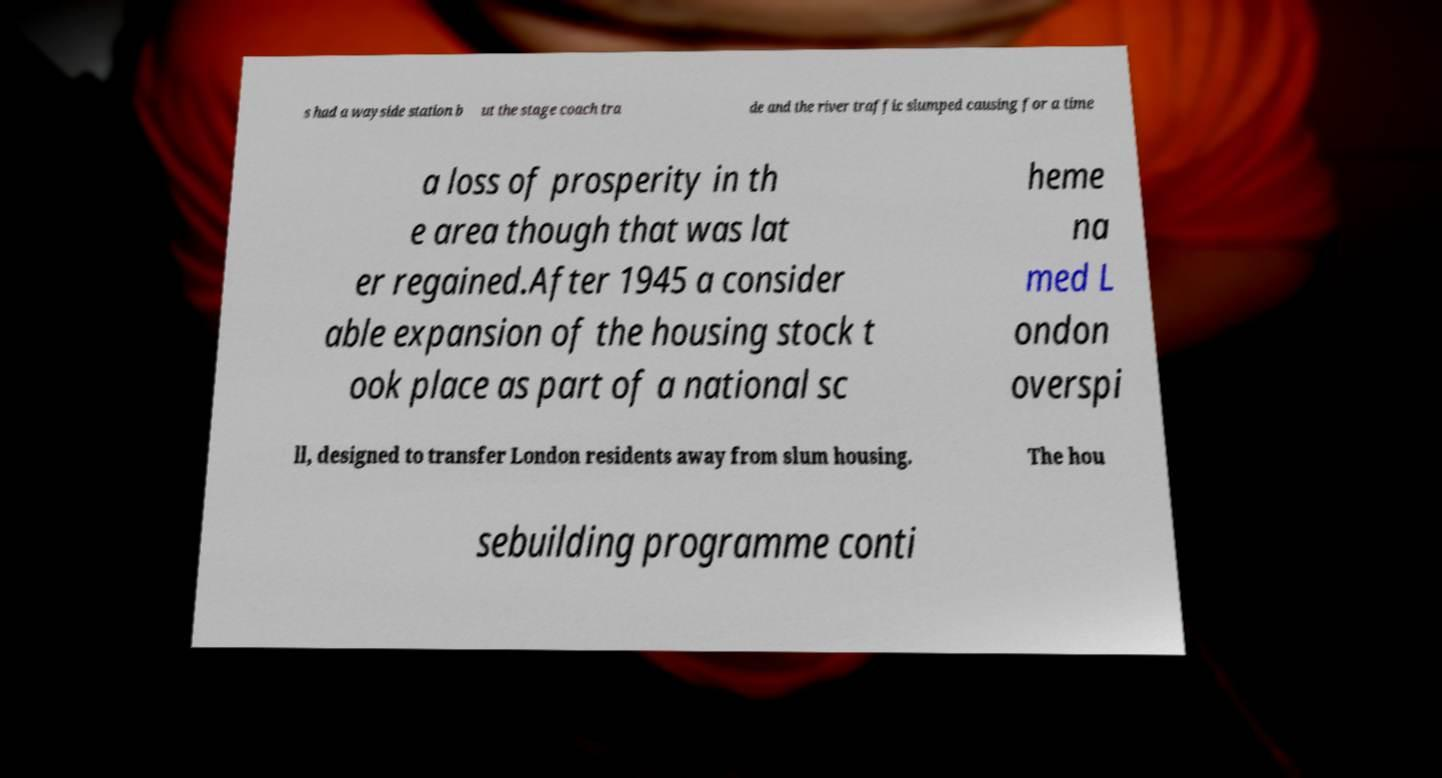Please read and relay the text visible in this image. What does it say? s had a wayside station b ut the stage coach tra de and the river traffic slumped causing for a time a loss of prosperity in th e area though that was lat er regained.After 1945 a consider able expansion of the housing stock t ook place as part of a national sc heme na med L ondon overspi ll, designed to transfer London residents away from slum housing. The hou sebuilding programme conti 